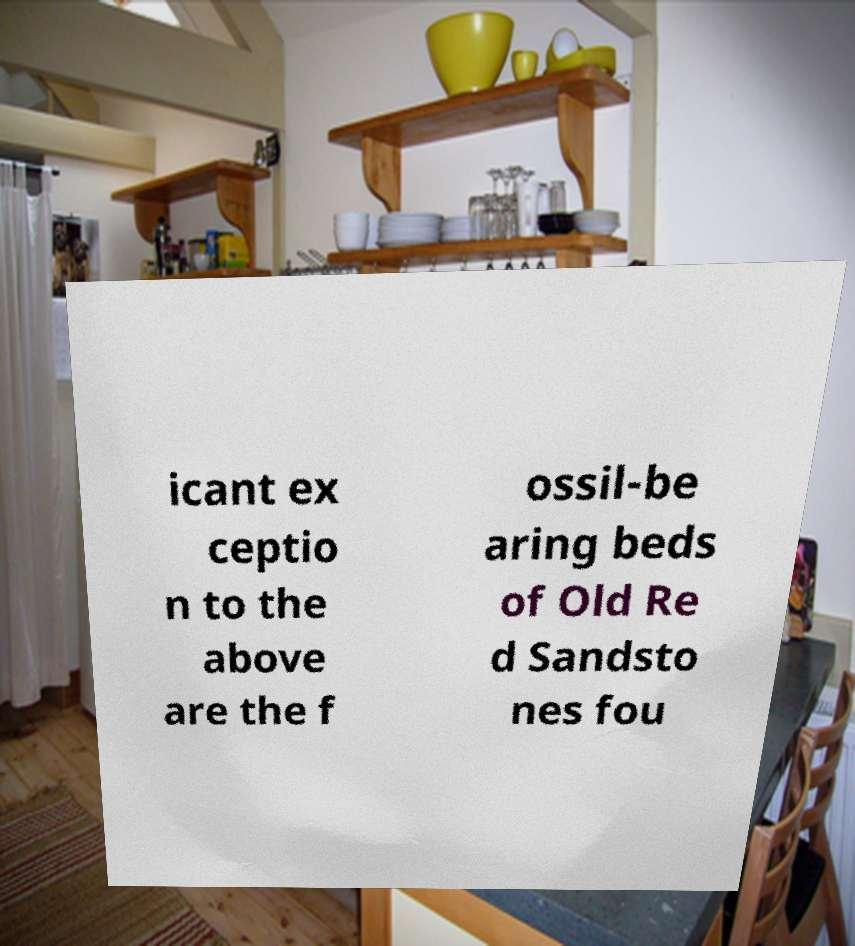Could you assist in decoding the text presented in this image and type it out clearly? icant ex ceptio n to the above are the f ossil-be aring beds of Old Re d Sandsto nes fou 